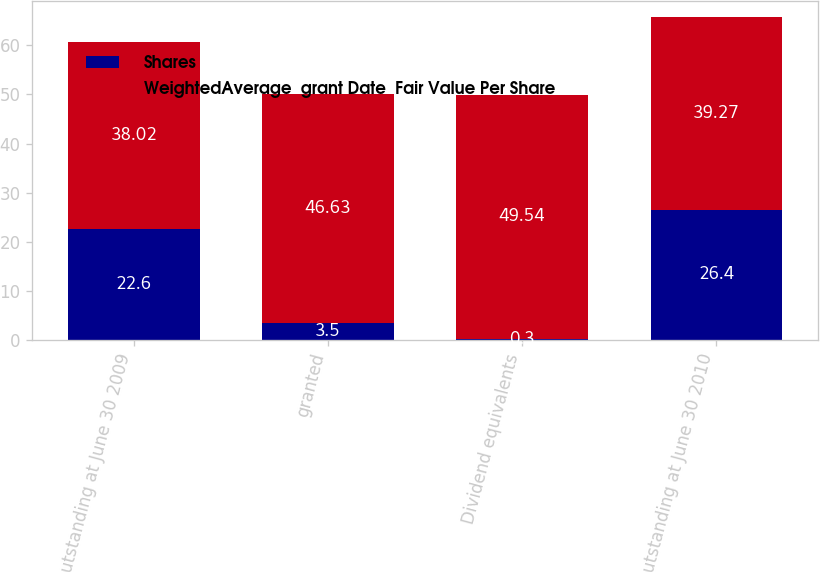<chart> <loc_0><loc_0><loc_500><loc_500><stacked_bar_chart><ecel><fcel>Outstanding at June 30 2009<fcel>granted<fcel>Dividend equivalents<fcel>Outstanding at June 30 2010<nl><fcel>Shares<fcel>22.6<fcel>3.5<fcel>0.3<fcel>26.4<nl><fcel>WeightedAverage  grant Date  Fair Value Per Share<fcel>38.02<fcel>46.63<fcel>49.54<fcel>39.27<nl></chart> 